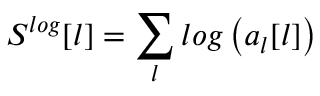Convert formula to latex. <formula><loc_0><loc_0><loc_500><loc_500>S ^ { \log } [ l ] = \sum _ { l } \log \left ( a _ { l } [ l ] \right )</formula> 